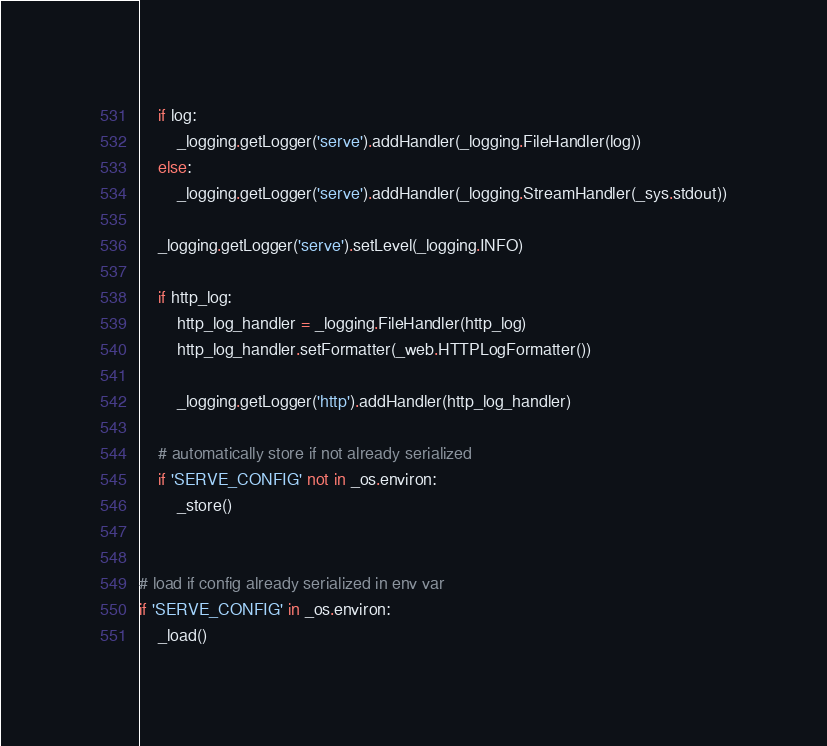Convert code to text. <code><loc_0><loc_0><loc_500><loc_500><_Python_>    if log:
        _logging.getLogger('serve').addHandler(_logging.FileHandler(log))
    else:
        _logging.getLogger('serve').addHandler(_logging.StreamHandler(_sys.stdout))

    _logging.getLogger('serve').setLevel(_logging.INFO)

    if http_log:
        http_log_handler = _logging.FileHandler(http_log)
        http_log_handler.setFormatter(_web.HTTPLogFormatter())

        _logging.getLogger('http').addHandler(http_log_handler)

    # automatically store if not already serialized
    if 'SERVE_CONFIG' not in _os.environ:
        _store()


# load if config already serialized in env var
if 'SERVE_CONFIG' in _os.environ:
    _load()
</code> 